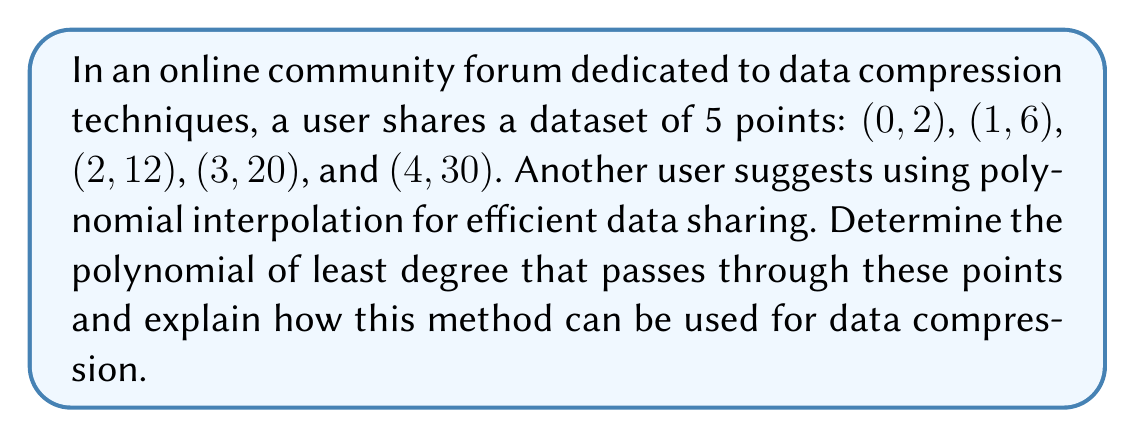Provide a solution to this math problem. To solve this problem, we'll use Lagrange polynomial interpolation, which is an efficient method for finding a polynomial that passes through a given set of points. This method is particularly useful in data compression and sharing scenarios.

Step 1: Set up the Lagrange interpolation formula
The Lagrange interpolation polynomial is given by:

$$P(x) = \sum_{i=0}^{n} y_i \prod_{j=0, j \neq i}^{n} \frac{x - x_j}{x_i - x_j}$$

Where $(x_i, y_i)$ are the given data points.

Step 2: Calculate the individual Lagrange basis polynomials
For each point, we calculate:

$$L_i(x) = \prod_{j=0, j \neq i}^{n} \frac{x - x_j}{x_i - x_j}$$

$L_0(x) = \frac{(x-1)(x-2)(x-3)(x-4)}{(0-1)(0-2)(0-3)(0-4)} = \frac{x^4 - 10x^3 + 35x^2 - 50x + 24}{24}$

$L_1(x) = \frac{(x-0)(x-2)(x-3)(x-4)}{(1-0)(1-2)(1-3)(1-4)} = -\frac{x^4 - 9x^3 + 29x^2 - 39x + 18}{6}$

$L_2(x) = \frac{(x-0)(x-1)(x-3)(x-4)}{(2-0)(2-1)(2-3)(2-4)} = \frac{x^4 - 8x^3 + 23x^2 - 28x + 12}{4}$

$L_3(x) = \frac{(x-0)(x-1)(x-2)(x-4)}{(3-0)(3-1)(3-2)(3-4)} = -\frac{x^4 - 7x^3 + 17x^2 - 17x + 6}{6}$

$L_4(x) = \frac{(x-0)(x-1)(x-2)(x-3)}{(4-0)(4-1)(4-2)(4-3)} = \frac{x^4 - 6x^3 + 11x^2 - 6x}{24}$

Step 3: Combine the Lagrange basis polynomials
Multiply each $L_i(x)$ by its corresponding $y_i$ value and sum:

$$P(x) = 2L_0(x) + 6L_1(x) + 12L_2(x) + 20L_3(x) + 30L_4(x)$$

Step 4: Simplify the resulting polynomial
After combining and simplifying, we get:

$$P(x) = \frac{1}{2}x^4 + \frac{1}{2}x^3 + x^2 + 2x + 2$$

This polynomial passes through all the given points and is of the least possible degree (4) for this dataset.

Data Compression Application:
Instead of sharing 5 individual data points, which would require 10 numbers (5 x-coordinates and 5 y-coordinates), we can now share just 5 coefficients of the polynomial. This reduces the amount of data to be transmitted while still preserving all the information. The recipient can reconstruct the original points or interpolate new points using this polynomial.

Additionally, if more points are needed between the given data points, they can be easily calculated using the polynomial, providing a smooth interpolation of the data.
Answer: The polynomial of least degree that passes through the given points is:

$$P(x) = \frac{1}{2}x^4 + \frac{1}{2}x^3 + x^2 + 2x + 2$$

This polynomial can be used for data compression by sharing its 5 coefficients instead of the original 5 data points, reducing the amount of data to be transmitted while preserving all the information. 